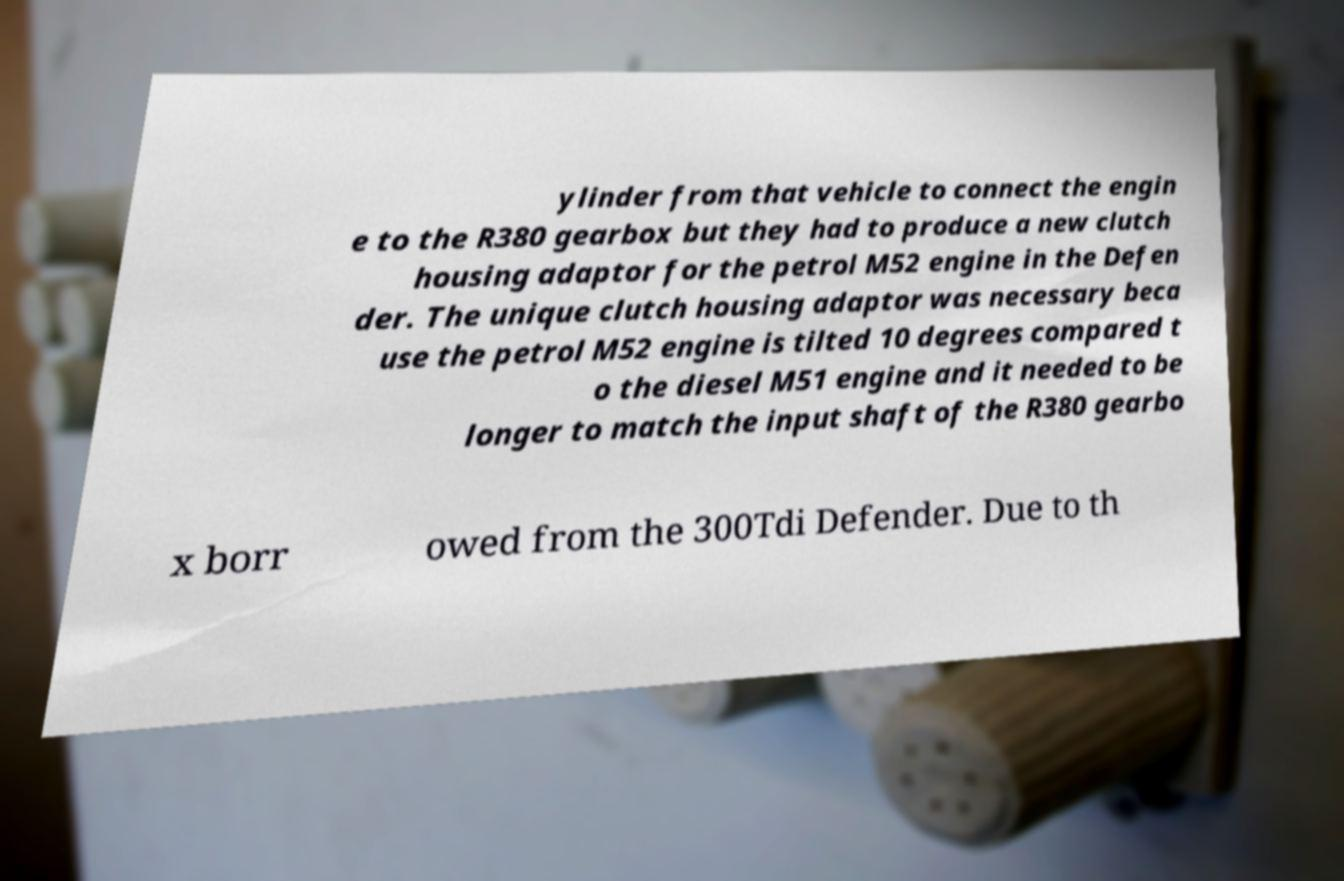Could you extract and type out the text from this image? ylinder from that vehicle to connect the engin e to the R380 gearbox but they had to produce a new clutch housing adaptor for the petrol M52 engine in the Defen der. The unique clutch housing adaptor was necessary beca use the petrol M52 engine is tilted 10 degrees compared t o the diesel M51 engine and it needed to be longer to match the input shaft of the R380 gearbo x borr owed from the 300Tdi Defender. Due to th 